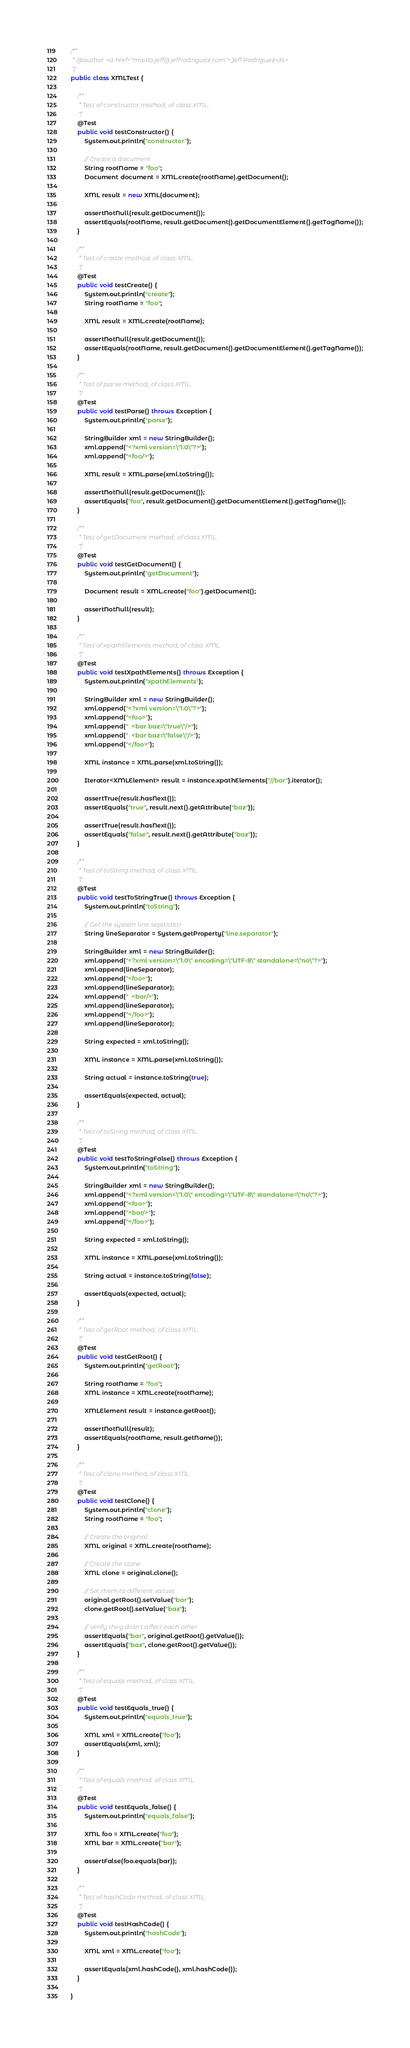<code> <loc_0><loc_0><loc_500><loc_500><_Java_>
/**
 * @author <a href="mailto:jeff@jeffrodriguez.com">Jeff Rodriguez</a>
 */
public class XMLTest {

    /**
     * Test of constructor method, of class XML.
     */
    @Test
    public void testConstructor() {
        System.out.println("constructor");

        // Create a document
        String rootName = "foo";
        Document document = XML.create(rootName).getDocument();

        XML result = new XML(document);

        assertNotNull(result.getDocument());
        assertEquals(rootName, result.getDocument().getDocumentElement().getTagName());
    }

    /**
     * Test of create method, of class XML.
     */
    @Test
    public void testCreate() {
        System.out.println("create");
        String rootName = "foo";

        XML result = XML.create(rootName);

        assertNotNull(result.getDocument());
        assertEquals(rootName, result.getDocument().getDocumentElement().getTagName());
    }

    /**
     * Test of parse method, of class XML.
     */
    @Test
    public void testParse() throws Exception {
        System.out.println("parse");

        StringBuilder xml = new StringBuilder();
        xml.append("<?xml version=\"1.0\"?>");
        xml.append("<foo/>");

        XML result = XML.parse(xml.toString());

        assertNotNull(result.getDocument());
        assertEquals("foo", result.getDocument().getDocumentElement().getTagName());
    }

    /**
     * Test of getDocument method, of class XML.
     */
    @Test
    public void testGetDocument() {
        System.out.println("getDocument");

        Document result = XML.create("foo").getDocument();

        assertNotNull(result);
    }

    /**
     * Test of xpathElements method, of class XML.
     */
    @Test
    public void testXpathElements() throws Exception {
        System.out.println("xpathElements");

        StringBuilder xml = new StringBuilder();
        xml.append("<?xml version=\"1.0\"?>");
        xml.append("<foo>");
        xml.append("  <bar baz=\"true\"/>");
        xml.append("  <bar baz=\"false\"/>");
        xml.append("</foo>");

        XML instance = XML.parse(xml.toString());

        Iterator<XMLElement> result = instance.xpathElements("//bar").iterator();

        assertTrue(result.hasNext());
        assertEquals("true", result.next().getAttribute("baz"));

        assertTrue(result.hasNext());
        assertEquals("false", result.next().getAttribute("baz"));
    }

    /**
     * Test of toString method, of class XML.
     */
    @Test
    public void testToStringTrue() throws Exception {
        System.out.println("toString");

        // Get the system line separator
        String lineSeparator = System.getProperty("line.separator");

        StringBuilder xml = new StringBuilder();
        xml.append("<?xml version=\"1.0\" encoding=\"UTF-8\" standalone=\"no\"?>");
        xml.append(lineSeparator);
        xml.append("<foo>");
        xml.append(lineSeparator);
        xml.append("  <bar/>");
        xml.append(lineSeparator);
        xml.append("</foo>");
        xml.append(lineSeparator);

        String expected = xml.toString();

        XML instance = XML.parse(xml.toString());

        String actual = instance.toString(true);

        assertEquals(expected, actual);
    }

    /**
     * Test of toString method, of class XML.
     */
    @Test
    public void testToStringFalse() throws Exception {
        System.out.println("toString");

        StringBuilder xml = new StringBuilder();
        xml.append("<?xml version=\"1.0\" encoding=\"UTF-8\" standalone=\"no\"?>");
        xml.append("<foo>");
        xml.append("<bar/>");
        xml.append("</foo>");

        String expected = xml.toString();

        XML instance = XML.parse(xml.toString());

        String actual = instance.toString(false);

        assertEquals(expected, actual);
    }

    /**
     * Test of getRoot method, of class XML.
     */
    @Test
    public void testGetRoot() {
        System.out.println("getRoot");

        String rootName = "foo";
        XML instance = XML.create(rootName);

        XMLElement result = instance.getRoot();

        assertNotNull(result);
        assertEquals(rootName, result.getName());
    }

    /**
     * Test of clone method, of class XML.
     */
    @Test
    public void testClone() {
        System.out.println("clone");
        String rootName = "foo";

        // Create the original
        XML original = XML.create(rootName);

        // Create the clone
        XML clone = original.clone();

        // Set them to different values
        original.getRoot().setValue("bar");
        clone.getRoot().setValue("baz");

        // Verify they didn't affect each other
        assertEquals("bar", original.getRoot().getValue());
        assertEquals("baz", clone.getRoot().getValue());
    }

    /**
     * Test of equals method, of class XML.
     */
    @Test
    public void testEquals_true() {
        System.out.println("equals_true");

        XML xml = XML.create("foo");
        assertEquals(xml, xml);
    }

    /**
     * Test of equals method, of class XML.
     */
    @Test
    public void testEquals_false() {
        System.out.println("equals_false");

        XML foo = XML.create("foo");
        XML bar = XML.create("bar");

        assertFalse(foo.equals(bar));
    }

    /**
     * Test of hashCode method, of class XML.
     */
    @Test
    public void testHashCode() {
        System.out.println("hashCode");

        XML xml = XML.create("foo");

        assertEquals(xml.hashCode(), xml.hashCode());
    }

}
</code> 